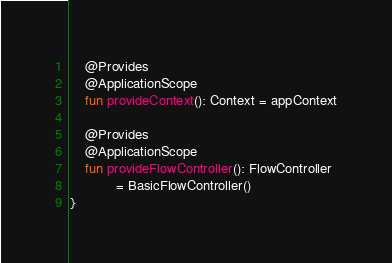<code> <loc_0><loc_0><loc_500><loc_500><_Kotlin_>    @Provides
    @ApplicationScope
    fun provideContext(): Context = appContext

    @Provides
    @ApplicationScope
    fun provideFlowController(): FlowController
            = BasicFlowController()
}</code> 